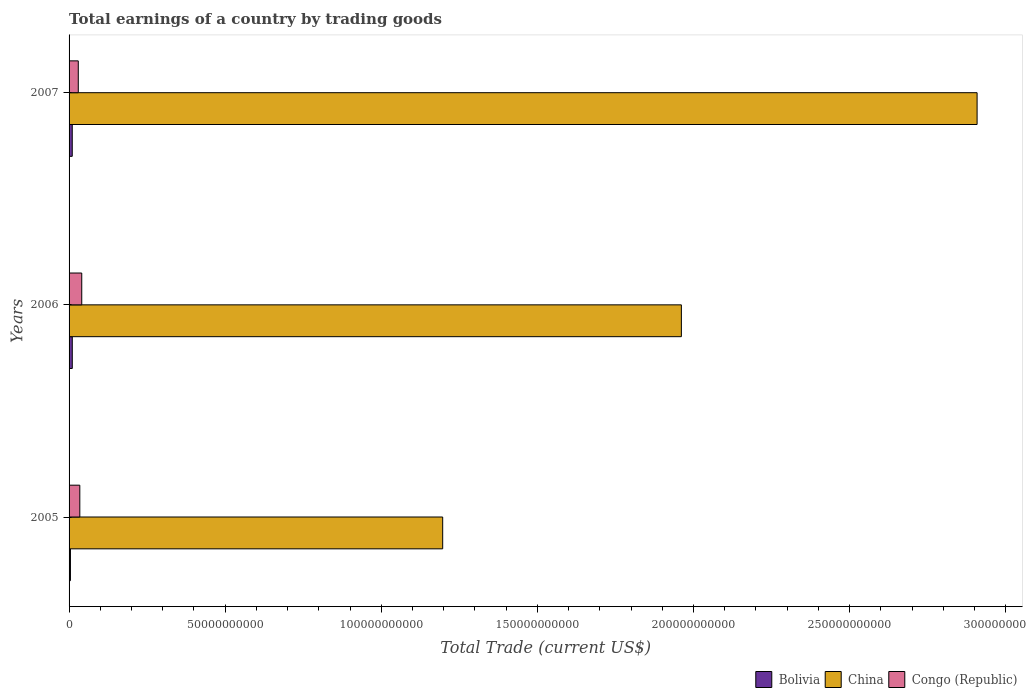How many different coloured bars are there?
Make the answer very short. 3. How many bars are there on the 1st tick from the top?
Ensure brevity in your answer.  3. How many bars are there on the 3rd tick from the bottom?
Give a very brief answer. 3. In how many cases, is the number of bars for a given year not equal to the number of legend labels?
Your response must be concise. 0. What is the total earnings in China in 2006?
Make the answer very short. 1.96e+11. Across all years, what is the maximum total earnings in China?
Ensure brevity in your answer.  2.91e+11. Across all years, what is the minimum total earnings in Bolivia?
Make the answer very short. 4.40e+08. In which year was the total earnings in Congo (Republic) maximum?
Your response must be concise. 2006. What is the total total earnings in Bolivia in the graph?
Make the answer very short. 2.49e+09. What is the difference between the total earnings in Congo (Republic) in 2005 and that in 2007?
Make the answer very short. 4.90e+08. What is the difference between the total earnings in Bolivia in 2006 and the total earnings in China in 2005?
Your response must be concise. -1.19e+11. What is the average total earnings in China per year?
Ensure brevity in your answer.  2.02e+11. In the year 2006, what is the difference between the total earnings in Congo (Republic) and total earnings in China?
Provide a short and direct response. -1.92e+11. In how many years, is the total earnings in Bolivia greater than 40000000000 US$?
Offer a terse response. 0. What is the ratio of the total earnings in China in 2005 to that in 2006?
Provide a succinct answer. 0.61. Is the total earnings in China in 2006 less than that in 2007?
Offer a terse response. Yes. What is the difference between the highest and the second highest total earnings in China?
Your answer should be very brief. 9.47e+1. What is the difference between the highest and the lowest total earnings in Bolivia?
Your answer should be very brief. 5.90e+08. Is the sum of the total earnings in China in 2006 and 2007 greater than the maximum total earnings in Bolivia across all years?
Offer a very short reply. Yes. What does the 2nd bar from the bottom in 2006 represents?
Your response must be concise. China. Are all the bars in the graph horizontal?
Your response must be concise. Yes. How many years are there in the graph?
Your answer should be very brief. 3. Does the graph contain any zero values?
Your response must be concise. No. Does the graph contain grids?
Offer a very short reply. No. How many legend labels are there?
Offer a terse response. 3. What is the title of the graph?
Your answer should be very brief. Total earnings of a country by trading goods. What is the label or title of the X-axis?
Give a very brief answer. Total Trade (current US$). What is the label or title of the Y-axis?
Make the answer very short. Years. What is the Total Trade (current US$) of Bolivia in 2005?
Your answer should be compact. 4.40e+08. What is the Total Trade (current US$) of China in 2005?
Offer a very short reply. 1.20e+11. What is the Total Trade (current US$) in Congo (Republic) in 2005?
Make the answer very short. 3.44e+09. What is the Total Trade (current US$) in Bolivia in 2006?
Provide a succinct answer. 1.03e+09. What is the Total Trade (current US$) of China in 2006?
Give a very brief answer. 1.96e+11. What is the Total Trade (current US$) in Congo (Republic) in 2006?
Provide a short and direct response. 4.06e+09. What is the Total Trade (current US$) in Bolivia in 2007?
Provide a short and direct response. 1.02e+09. What is the Total Trade (current US$) in China in 2007?
Provide a succinct answer. 2.91e+11. What is the Total Trade (current US$) of Congo (Republic) in 2007?
Offer a terse response. 2.95e+09. Across all years, what is the maximum Total Trade (current US$) in Bolivia?
Offer a very short reply. 1.03e+09. Across all years, what is the maximum Total Trade (current US$) of China?
Your answer should be compact. 2.91e+11. Across all years, what is the maximum Total Trade (current US$) in Congo (Republic)?
Offer a terse response. 4.06e+09. Across all years, what is the minimum Total Trade (current US$) in Bolivia?
Make the answer very short. 4.40e+08. Across all years, what is the minimum Total Trade (current US$) in China?
Give a very brief answer. 1.20e+11. Across all years, what is the minimum Total Trade (current US$) in Congo (Republic)?
Offer a very short reply. 2.95e+09. What is the total Total Trade (current US$) of Bolivia in the graph?
Give a very brief answer. 2.49e+09. What is the total Total Trade (current US$) of China in the graph?
Give a very brief answer. 6.07e+11. What is the total Total Trade (current US$) in Congo (Republic) in the graph?
Give a very brief answer. 1.05e+1. What is the difference between the Total Trade (current US$) in Bolivia in 2005 and that in 2006?
Ensure brevity in your answer.  -5.90e+08. What is the difference between the Total Trade (current US$) in China in 2005 and that in 2006?
Give a very brief answer. -7.64e+1. What is the difference between the Total Trade (current US$) of Congo (Republic) in 2005 and that in 2006?
Offer a very short reply. -6.22e+08. What is the difference between the Total Trade (current US$) of Bolivia in 2005 and that in 2007?
Offer a very short reply. -5.80e+08. What is the difference between the Total Trade (current US$) of China in 2005 and that in 2007?
Offer a very short reply. -1.71e+11. What is the difference between the Total Trade (current US$) of Congo (Republic) in 2005 and that in 2007?
Offer a very short reply. 4.90e+08. What is the difference between the Total Trade (current US$) in Bolivia in 2006 and that in 2007?
Provide a short and direct response. 1.05e+07. What is the difference between the Total Trade (current US$) of China in 2006 and that in 2007?
Ensure brevity in your answer.  -9.47e+1. What is the difference between the Total Trade (current US$) in Congo (Republic) in 2006 and that in 2007?
Your answer should be very brief. 1.11e+09. What is the difference between the Total Trade (current US$) of Bolivia in 2005 and the Total Trade (current US$) of China in 2006?
Your response must be concise. -1.96e+11. What is the difference between the Total Trade (current US$) in Bolivia in 2005 and the Total Trade (current US$) in Congo (Republic) in 2006?
Provide a short and direct response. -3.62e+09. What is the difference between the Total Trade (current US$) of China in 2005 and the Total Trade (current US$) of Congo (Republic) in 2006?
Offer a very short reply. 1.16e+11. What is the difference between the Total Trade (current US$) in Bolivia in 2005 and the Total Trade (current US$) in China in 2007?
Your response must be concise. -2.90e+11. What is the difference between the Total Trade (current US$) of Bolivia in 2005 and the Total Trade (current US$) of Congo (Republic) in 2007?
Give a very brief answer. -2.51e+09. What is the difference between the Total Trade (current US$) in China in 2005 and the Total Trade (current US$) in Congo (Republic) in 2007?
Provide a succinct answer. 1.17e+11. What is the difference between the Total Trade (current US$) in Bolivia in 2006 and the Total Trade (current US$) in China in 2007?
Your answer should be compact. -2.90e+11. What is the difference between the Total Trade (current US$) of Bolivia in 2006 and the Total Trade (current US$) of Congo (Republic) in 2007?
Your answer should be compact. -1.92e+09. What is the difference between the Total Trade (current US$) in China in 2006 and the Total Trade (current US$) in Congo (Republic) in 2007?
Give a very brief answer. 1.93e+11. What is the average Total Trade (current US$) of Bolivia per year?
Offer a very short reply. 8.30e+08. What is the average Total Trade (current US$) in China per year?
Give a very brief answer. 2.02e+11. What is the average Total Trade (current US$) in Congo (Republic) per year?
Keep it short and to the point. 3.48e+09. In the year 2005, what is the difference between the Total Trade (current US$) in Bolivia and Total Trade (current US$) in China?
Offer a very short reply. -1.19e+11. In the year 2005, what is the difference between the Total Trade (current US$) in Bolivia and Total Trade (current US$) in Congo (Republic)?
Offer a terse response. -3.00e+09. In the year 2005, what is the difference between the Total Trade (current US$) of China and Total Trade (current US$) of Congo (Republic)?
Your answer should be very brief. 1.16e+11. In the year 2006, what is the difference between the Total Trade (current US$) in Bolivia and Total Trade (current US$) in China?
Make the answer very short. -1.95e+11. In the year 2006, what is the difference between the Total Trade (current US$) in Bolivia and Total Trade (current US$) in Congo (Republic)?
Ensure brevity in your answer.  -3.03e+09. In the year 2006, what is the difference between the Total Trade (current US$) in China and Total Trade (current US$) in Congo (Republic)?
Ensure brevity in your answer.  1.92e+11. In the year 2007, what is the difference between the Total Trade (current US$) of Bolivia and Total Trade (current US$) of China?
Keep it short and to the point. -2.90e+11. In the year 2007, what is the difference between the Total Trade (current US$) in Bolivia and Total Trade (current US$) in Congo (Republic)?
Keep it short and to the point. -1.93e+09. In the year 2007, what is the difference between the Total Trade (current US$) of China and Total Trade (current US$) of Congo (Republic)?
Your response must be concise. 2.88e+11. What is the ratio of the Total Trade (current US$) in Bolivia in 2005 to that in 2006?
Provide a short and direct response. 0.43. What is the ratio of the Total Trade (current US$) of China in 2005 to that in 2006?
Your response must be concise. 0.61. What is the ratio of the Total Trade (current US$) in Congo (Republic) in 2005 to that in 2006?
Your answer should be compact. 0.85. What is the ratio of the Total Trade (current US$) in Bolivia in 2005 to that in 2007?
Your answer should be compact. 0.43. What is the ratio of the Total Trade (current US$) of China in 2005 to that in 2007?
Ensure brevity in your answer.  0.41. What is the ratio of the Total Trade (current US$) of Congo (Republic) in 2005 to that in 2007?
Make the answer very short. 1.17. What is the ratio of the Total Trade (current US$) in Bolivia in 2006 to that in 2007?
Offer a very short reply. 1.01. What is the ratio of the Total Trade (current US$) of China in 2006 to that in 2007?
Offer a very short reply. 0.67. What is the ratio of the Total Trade (current US$) in Congo (Republic) in 2006 to that in 2007?
Keep it short and to the point. 1.38. What is the difference between the highest and the second highest Total Trade (current US$) in Bolivia?
Your response must be concise. 1.05e+07. What is the difference between the highest and the second highest Total Trade (current US$) of China?
Your answer should be very brief. 9.47e+1. What is the difference between the highest and the second highest Total Trade (current US$) of Congo (Republic)?
Your response must be concise. 6.22e+08. What is the difference between the highest and the lowest Total Trade (current US$) in Bolivia?
Provide a succinct answer. 5.90e+08. What is the difference between the highest and the lowest Total Trade (current US$) in China?
Your answer should be very brief. 1.71e+11. What is the difference between the highest and the lowest Total Trade (current US$) of Congo (Republic)?
Your answer should be compact. 1.11e+09. 